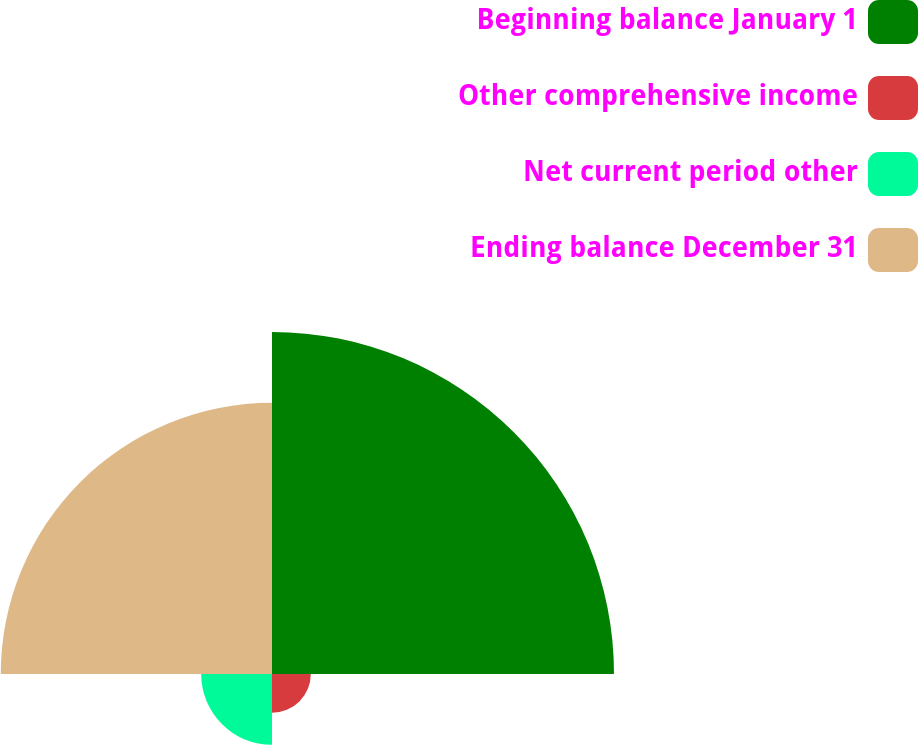Convert chart to OTSL. <chart><loc_0><loc_0><loc_500><loc_500><pie_chart><fcel>Beginning balance January 1<fcel>Other comprehensive income<fcel>Net current period other<fcel>Ending balance December 31<nl><fcel>47.31%<fcel>5.37%<fcel>9.8%<fcel>37.52%<nl></chart> 